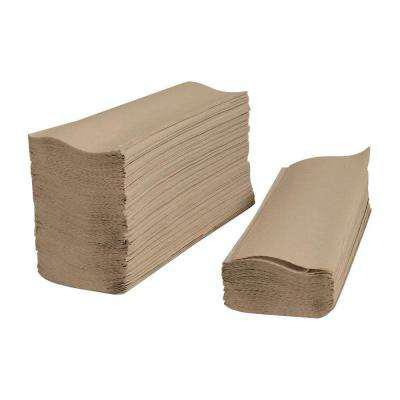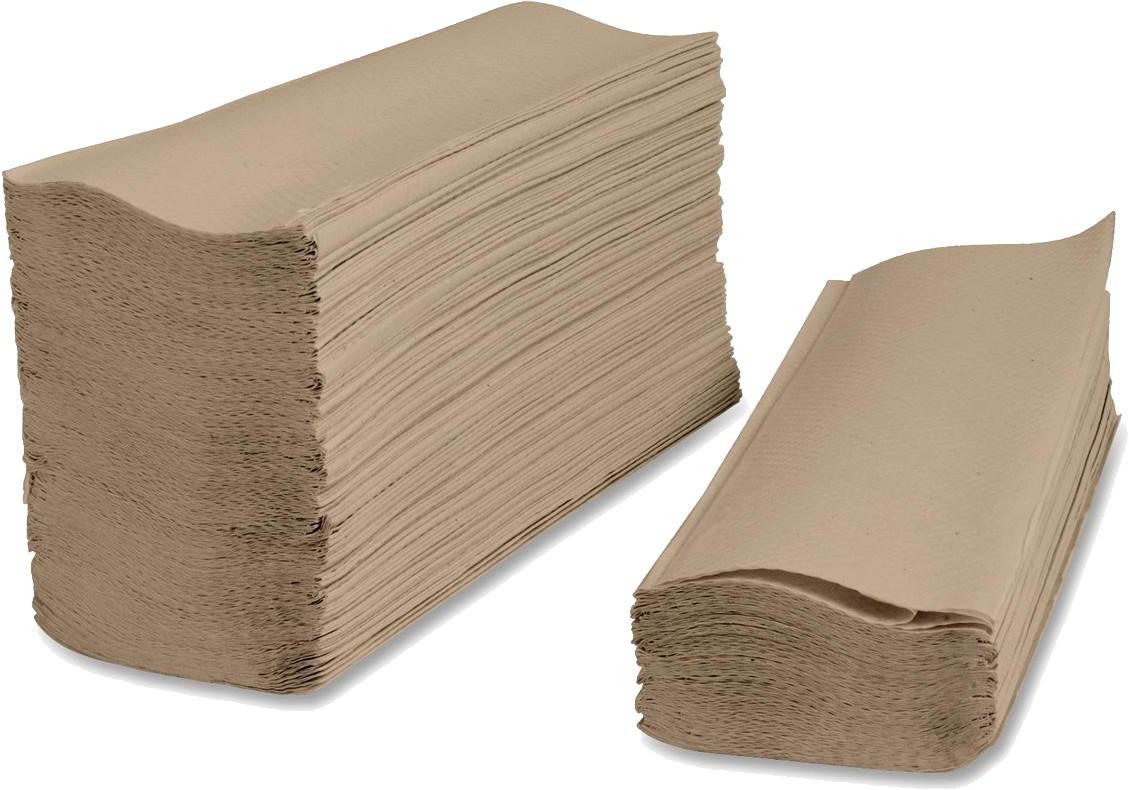The first image is the image on the left, the second image is the image on the right. Examine the images to the left and right. Is the description "There is at least one roll of brown paper in the image on the left." accurate? Answer yes or no. No. The first image is the image on the left, the second image is the image on the right. Considering the images on both sides, is "Both paper rolls and paper towel stacks are shown." valid? Answer yes or no. No. 